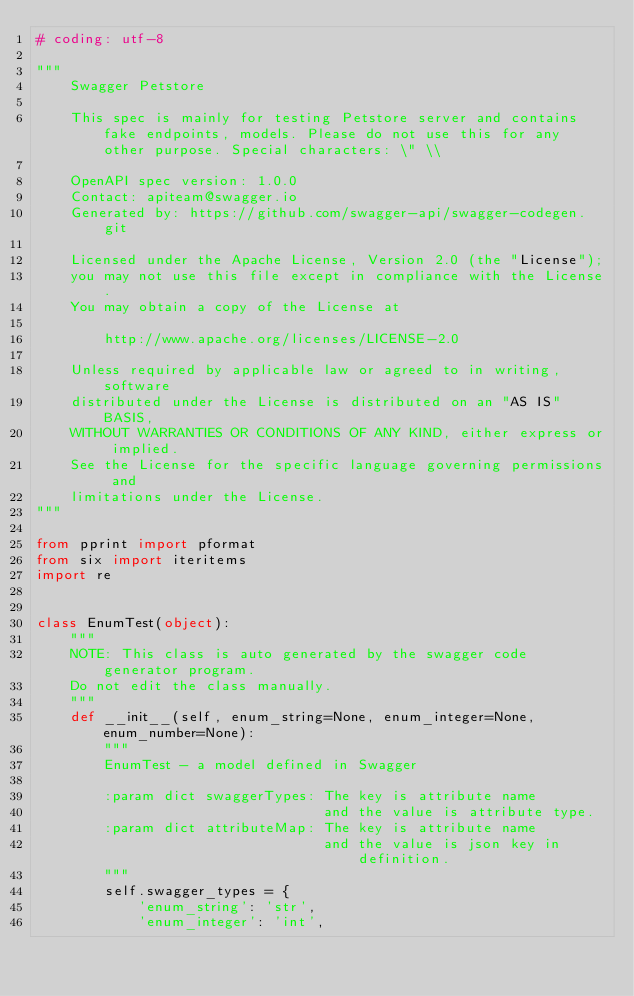Convert code to text. <code><loc_0><loc_0><loc_500><loc_500><_Python_># coding: utf-8

"""
    Swagger Petstore

    This spec is mainly for testing Petstore server and contains fake endpoints, models. Please do not use this for any other purpose. Special characters: \" \\

    OpenAPI spec version: 1.0.0
    Contact: apiteam@swagger.io
    Generated by: https://github.com/swagger-api/swagger-codegen.git

    Licensed under the Apache License, Version 2.0 (the "License");
    you may not use this file except in compliance with the License.
    You may obtain a copy of the License at

        http://www.apache.org/licenses/LICENSE-2.0

    Unless required by applicable law or agreed to in writing, software
    distributed under the License is distributed on an "AS IS" BASIS,
    WITHOUT WARRANTIES OR CONDITIONS OF ANY KIND, either express or implied.
    See the License for the specific language governing permissions and
    limitations under the License.
"""

from pprint import pformat
from six import iteritems
import re


class EnumTest(object):
    """
    NOTE: This class is auto generated by the swagger code generator program.
    Do not edit the class manually.
    """
    def __init__(self, enum_string=None, enum_integer=None, enum_number=None):
        """
        EnumTest - a model defined in Swagger

        :param dict swaggerTypes: The key is attribute name
                                  and the value is attribute type.
        :param dict attributeMap: The key is attribute name
                                  and the value is json key in definition.
        """
        self.swagger_types = {
            'enum_string': 'str',
            'enum_integer': 'int',</code> 